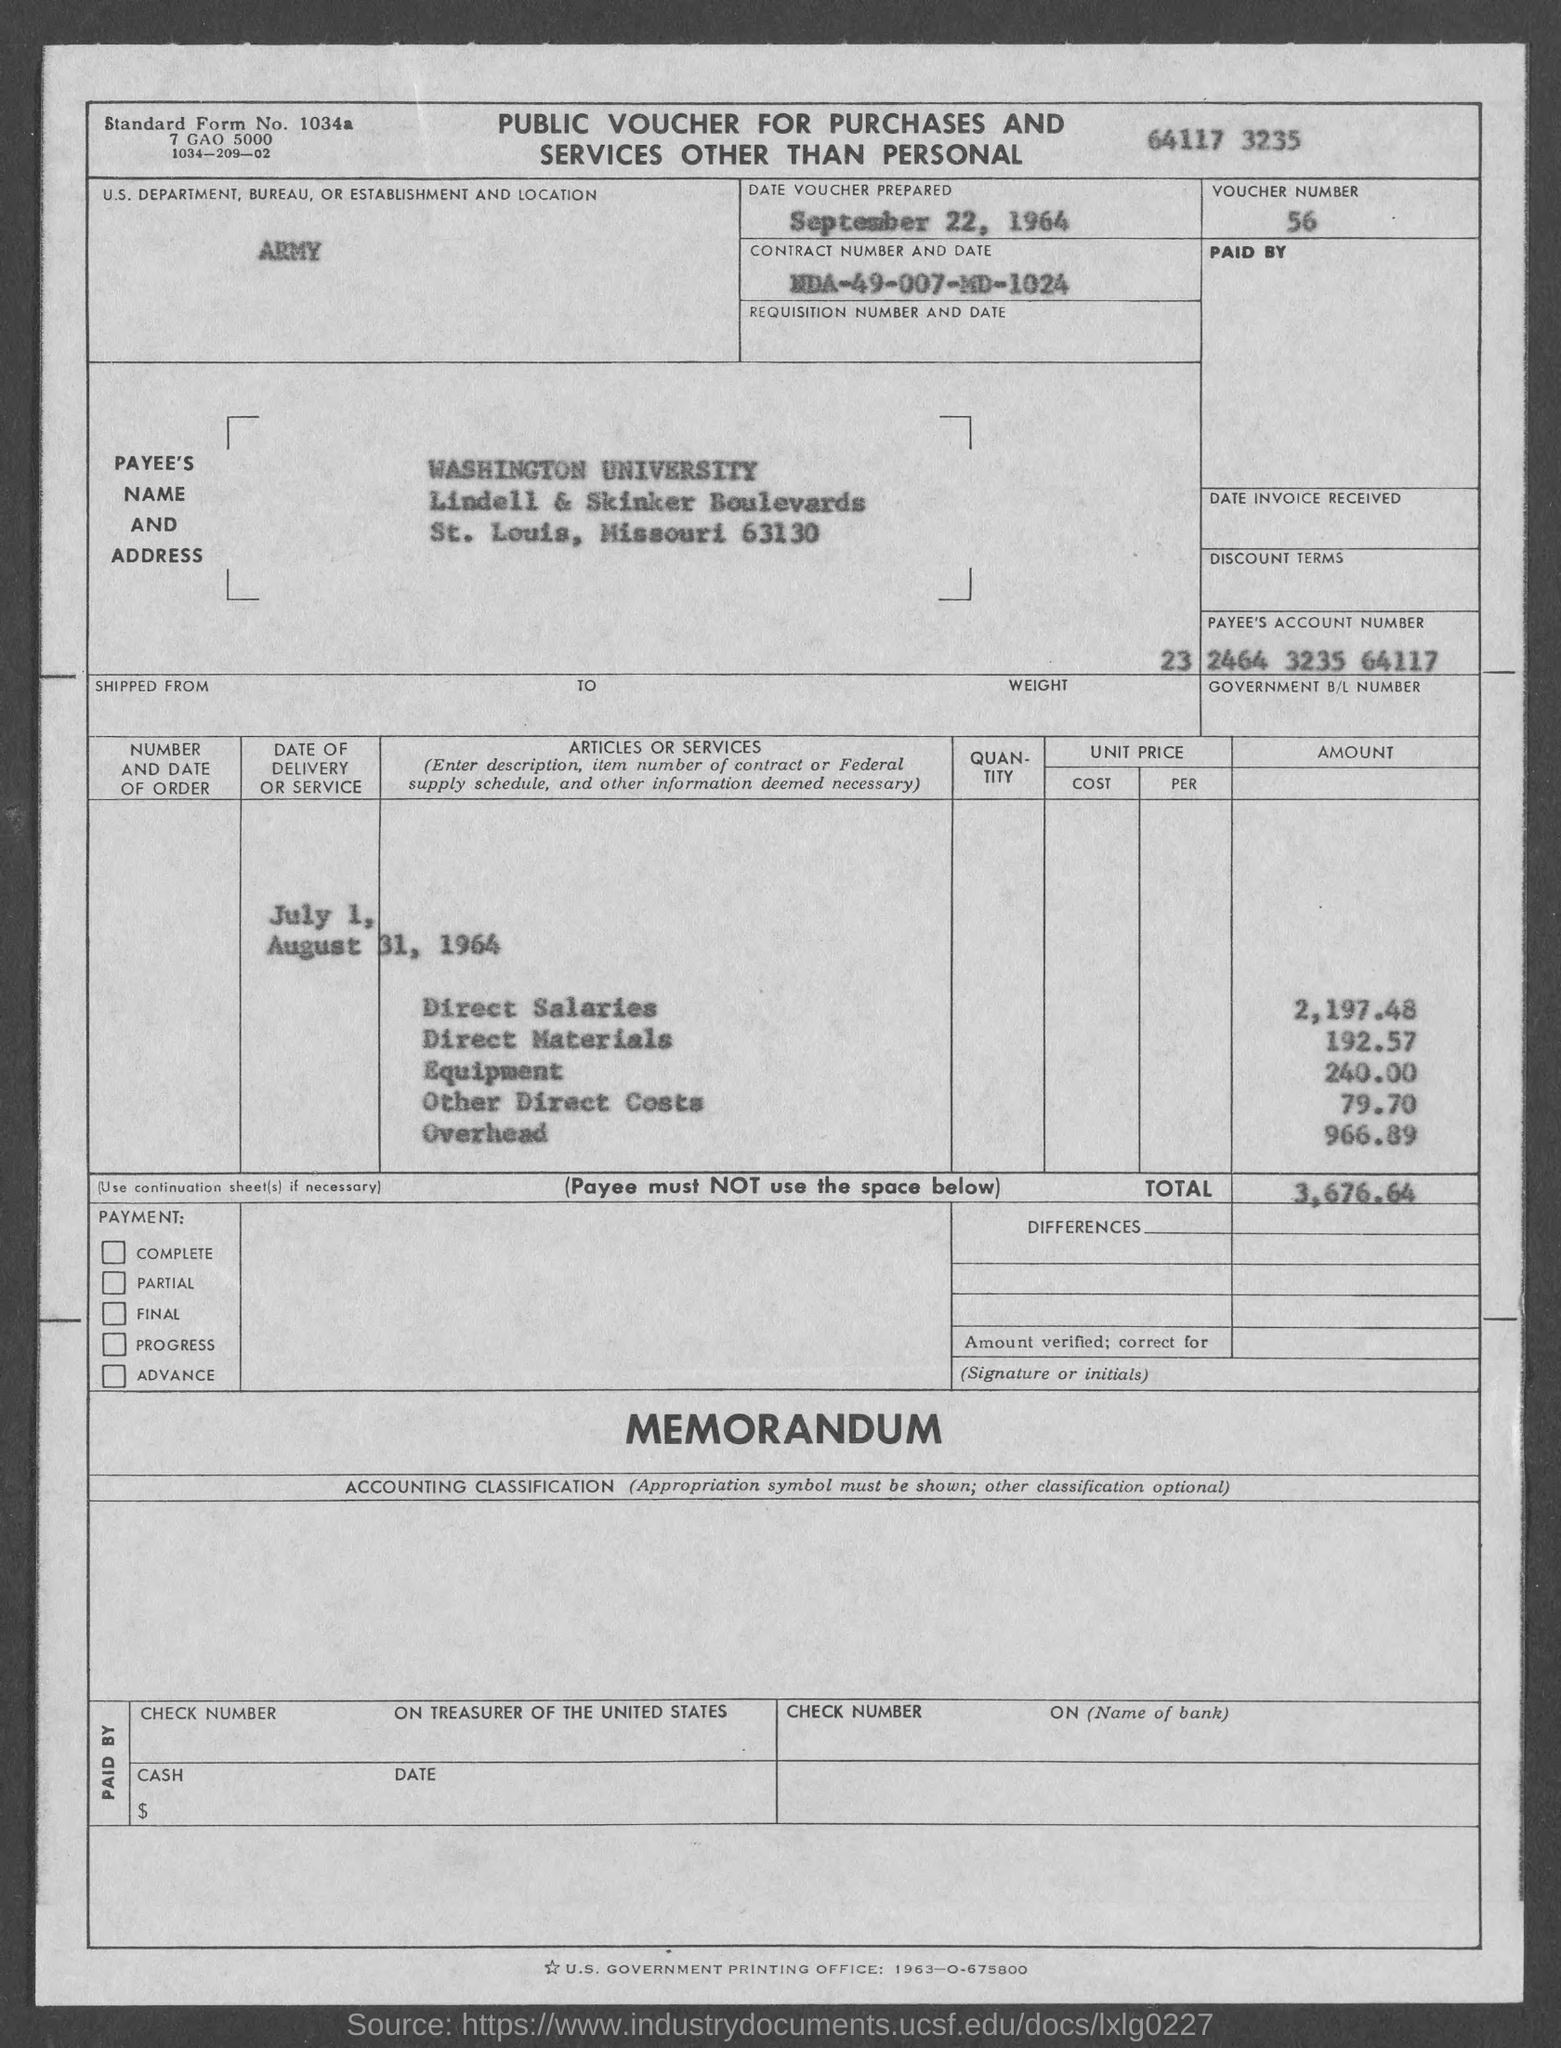What is the Direct salaries amount? The Direct Salaries amount listed on the document for July 1, 1964, through August 31, 1964, is exactly $2,197.48. 